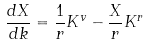<formula> <loc_0><loc_0><loc_500><loc_500>\frac { d X } { d k } = \frac { 1 } { r } K ^ { v } - \frac { X } { r } K ^ { r }</formula> 